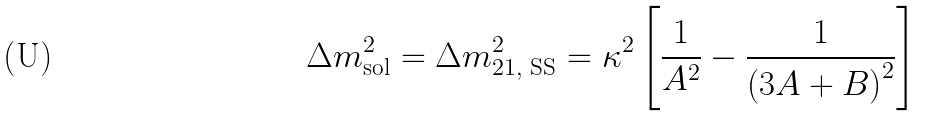Convert formula to latex. <formula><loc_0><loc_0><loc_500><loc_500>\Delta m _ { \text {sol} } ^ { 2 } = \Delta m _ { 2 1 , \text { SS} } ^ { 2 } = \kappa ^ { 2 } \left [ \frac { 1 } { A ^ { 2 } } - \frac { 1 } { \left ( 3 A + B \right ) ^ { 2 } } \right ]</formula> 